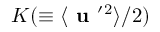<formula> <loc_0><loc_0><loc_500><loc_500>K ( \equiv \langle { { u } ^ { \prime ^ { 2 } } \rangle / 2 )</formula> 